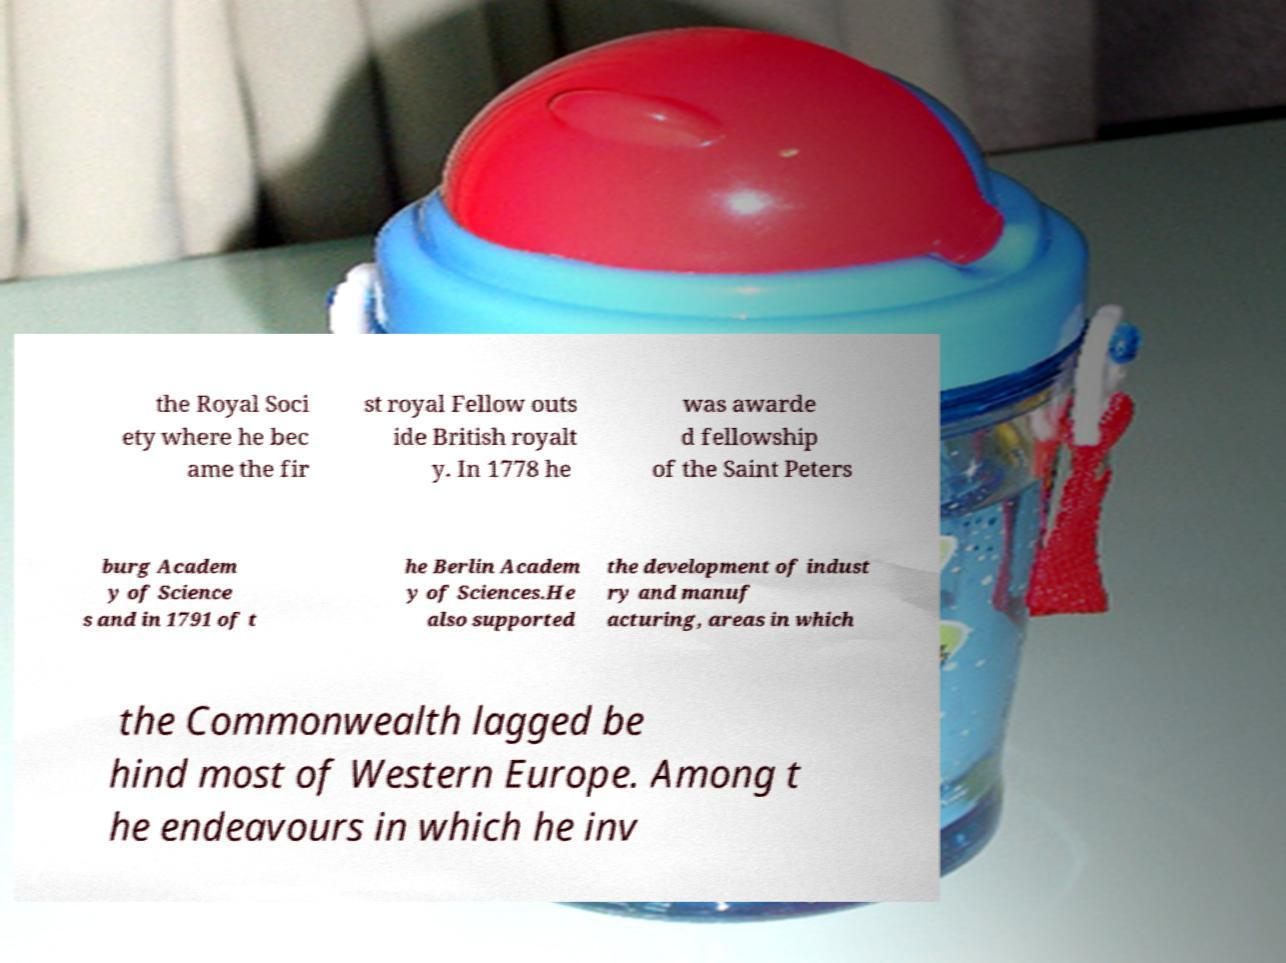Can you accurately transcribe the text from the provided image for me? the Royal Soci ety where he bec ame the fir st royal Fellow outs ide British royalt y. In 1778 he was awarde d fellowship of the Saint Peters burg Academ y of Science s and in 1791 of t he Berlin Academ y of Sciences.He also supported the development of indust ry and manuf acturing, areas in which the Commonwealth lagged be hind most of Western Europe. Among t he endeavours in which he inv 